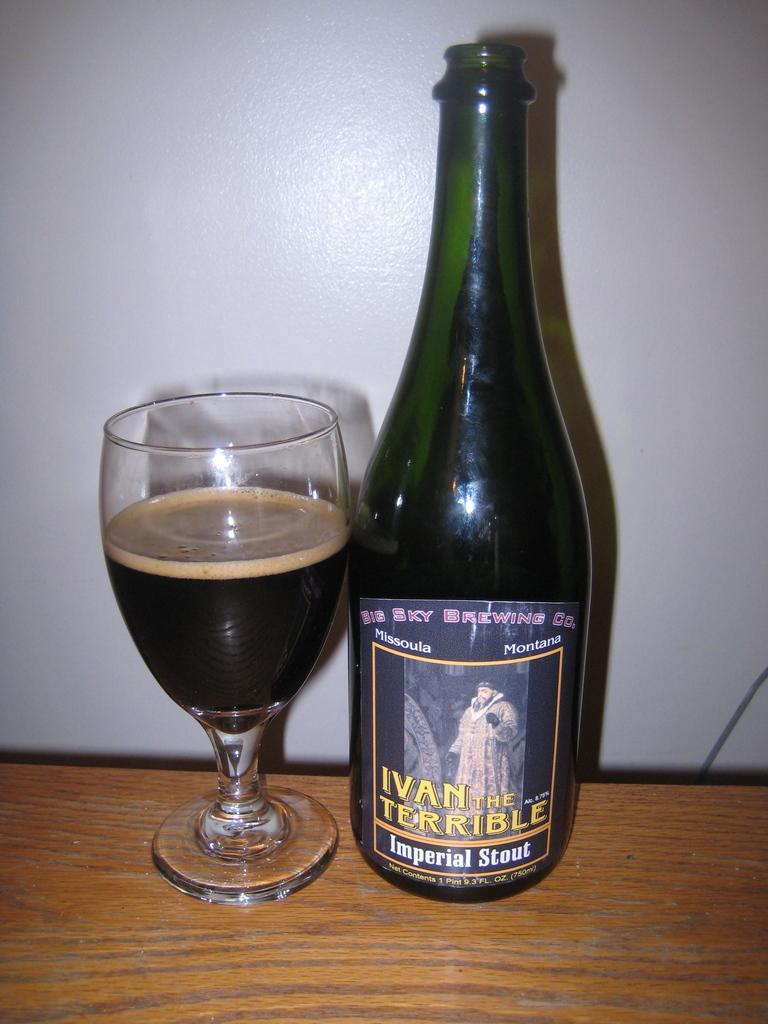Provide a one-sentence caption for the provided image. An Imperial Stout is poured into a glass on the table. 